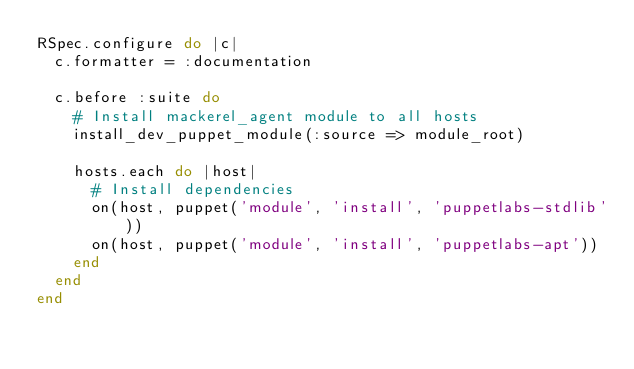<code> <loc_0><loc_0><loc_500><loc_500><_Ruby_>RSpec.configure do |c|
  c.formatter = :documentation

  c.before :suite do
    # Install mackerel_agent module to all hosts
    install_dev_puppet_module(:source => module_root)

    hosts.each do |host|
      # Install dependencies
      on(host, puppet('module', 'install', 'puppetlabs-stdlib'))
      on(host, puppet('module', 'install', 'puppetlabs-apt'))
    end
  end
end
</code> 